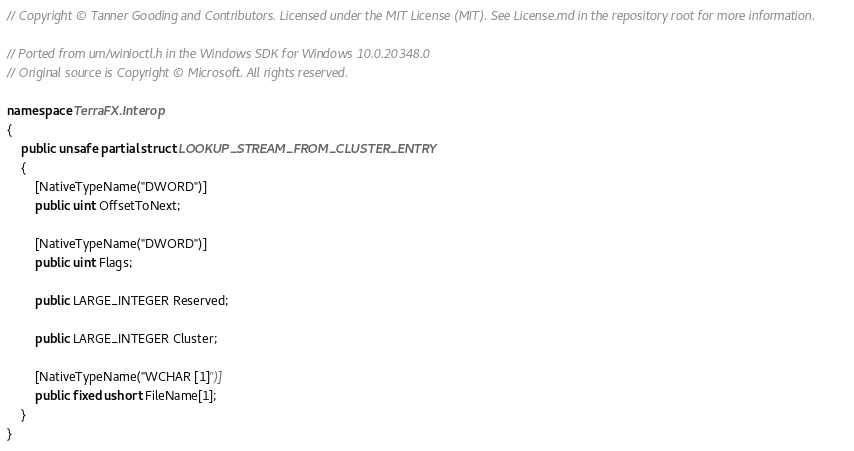<code> <loc_0><loc_0><loc_500><loc_500><_C#_>// Copyright © Tanner Gooding and Contributors. Licensed under the MIT License (MIT). See License.md in the repository root for more information.

// Ported from um/winioctl.h in the Windows SDK for Windows 10.0.20348.0
// Original source is Copyright © Microsoft. All rights reserved.

namespace TerraFX.Interop
{
    public unsafe partial struct LOOKUP_STREAM_FROM_CLUSTER_ENTRY
    {
        [NativeTypeName("DWORD")]
        public uint OffsetToNext;

        [NativeTypeName("DWORD")]
        public uint Flags;

        public LARGE_INTEGER Reserved;

        public LARGE_INTEGER Cluster;

        [NativeTypeName("WCHAR [1]")]
        public fixed ushort FileName[1];
    }
}
</code> 